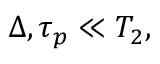<formula> <loc_0><loc_0><loc_500><loc_500>\begin{array} { r } { \Delta , \tau _ { p } \ll T _ { 2 } , } \end{array}</formula> 